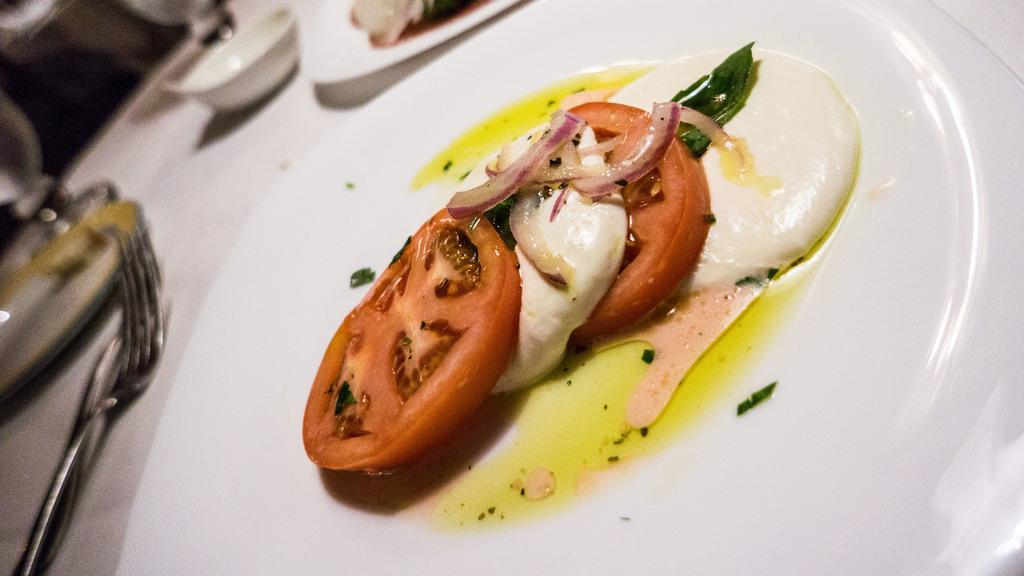What piece of furniture is present in the image? There is a table in the image. What items are placed on the table? There are plates, food, cups, forks, spoons, and glasses on the table. How many types of utensils can be seen on the table? There are two types of utensils on the table: forks and spoons. What type of twig is being used as a representative to determine the value of the food in the image? There is no twig present in the image, and no representative is being used to determine the value of the food. 